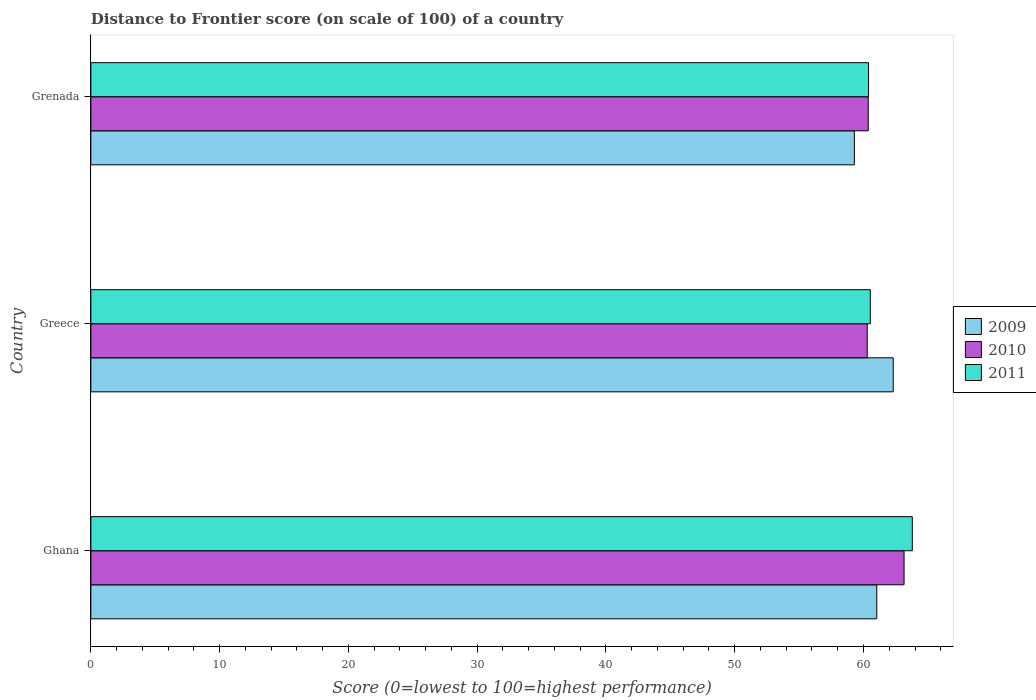How many different coloured bars are there?
Keep it short and to the point. 3. In how many cases, is the number of bars for a given country not equal to the number of legend labels?
Make the answer very short. 0. What is the distance to frontier score of in 2010 in Greece?
Keep it short and to the point. 60.29. Across all countries, what is the maximum distance to frontier score of in 2010?
Your answer should be very brief. 63.15. Across all countries, what is the minimum distance to frontier score of in 2010?
Ensure brevity in your answer.  60.29. In which country was the distance to frontier score of in 2009 maximum?
Offer a terse response. Greece. In which country was the distance to frontier score of in 2010 minimum?
Make the answer very short. Greece. What is the total distance to frontier score of in 2011 in the graph?
Your answer should be very brief. 184.71. What is the difference between the distance to frontier score of in 2009 in Ghana and that in Grenada?
Provide a succinct answer. 1.74. What is the difference between the distance to frontier score of in 2009 in Greece and the distance to frontier score of in 2010 in Grenada?
Keep it short and to the point. 1.94. What is the average distance to frontier score of in 2011 per country?
Keep it short and to the point. 61.57. What is the difference between the distance to frontier score of in 2011 and distance to frontier score of in 2009 in Grenada?
Your response must be concise. 1.1. In how many countries, is the distance to frontier score of in 2011 greater than 22 ?
Give a very brief answer. 3. What is the ratio of the distance to frontier score of in 2011 in Ghana to that in Grenada?
Give a very brief answer. 1.06. Is the distance to frontier score of in 2011 in Greece less than that in Grenada?
Give a very brief answer. No. What is the difference between the highest and the second highest distance to frontier score of in 2009?
Make the answer very short. 1.28. What is the difference between the highest and the lowest distance to frontier score of in 2010?
Your response must be concise. 2.86. What does the 3rd bar from the top in Ghana represents?
Provide a short and direct response. 2009. How many bars are there?
Your response must be concise. 9. What is the difference between two consecutive major ticks on the X-axis?
Provide a short and direct response. 10. Are the values on the major ticks of X-axis written in scientific E-notation?
Provide a succinct answer. No. Does the graph contain grids?
Offer a terse response. No. How many legend labels are there?
Make the answer very short. 3. How are the legend labels stacked?
Give a very brief answer. Vertical. What is the title of the graph?
Your answer should be very brief. Distance to Frontier score (on scale of 100) of a country. Does "1977" appear as one of the legend labels in the graph?
Your answer should be very brief. No. What is the label or title of the X-axis?
Offer a terse response. Score (0=lowest to 100=highest performance). What is the label or title of the Y-axis?
Give a very brief answer. Country. What is the Score (0=lowest to 100=highest performance) in 2009 in Ghana?
Your answer should be very brief. 61.03. What is the Score (0=lowest to 100=highest performance) in 2010 in Ghana?
Keep it short and to the point. 63.15. What is the Score (0=lowest to 100=highest performance) of 2011 in Ghana?
Your response must be concise. 63.79. What is the Score (0=lowest to 100=highest performance) in 2009 in Greece?
Your response must be concise. 62.31. What is the Score (0=lowest to 100=highest performance) of 2010 in Greece?
Make the answer very short. 60.29. What is the Score (0=lowest to 100=highest performance) in 2011 in Greece?
Offer a terse response. 60.53. What is the Score (0=lowest to 100=highest performance) of 2009 in Grenada?
Your answer should be compact. 59.29. What is the Score (0=lowest to 100=highest performance) of 2010 in Grenada?
Your response must be concise. 60.37. What is the Score (0=lowest to 100=highest performance) of 2011 in Grenada?
Offer a very short reply. 60.39. Across all countries, what is the maximum Score (0=lowest to 100=highest performance) of 2009?
Give a very brief answer. 62.31. Across all countries, what is the maximum Score (0=lowest to 100=highest performance) of 2010?
Ensure brevity in your answer.  63.15. Across all countries, what is the maximum Score (0=lowest to 100=highest performance) in 2011?
Provide a short and direct response. 63.79. Across all countries, what is the minimum Score (0=lowest to 100=highest performance) in 2009?
Your answer should be compact. 59.29. Across all countries, what is the minimum Score (0=lowest to 100=highest performance) in 2010?
Your answer should be very brief. 60.29. Across all countries, what is the minimum Score (0=lowest to 100=highest performance) in 2011?
Ensure brevity in your answer.  60.39. What is the total Score (0=lowest to 100=highest performance) in 2009 in the graph?
Provide a short and direct response. 182.63. What is the total Score (0=lowest to 100=highest performance) in 2010 in the graph?
Make the answer very short. 183.81. What is the total Score (0=lowest to 100=highest performance) of 2011 in the graph?
Your response must be concise. 184.71. What is the difference between the Score (0=lowest to 100=highest performance) in 2009 in Ghana and that in Greece?
Your response must be concise. -1.28. What is the difference between the Score (0=lowest to 100=highest performance) of 2010 in Ghana and that in Greece?
Provide a short and direct response. 2.86. What is the difference between the Score (0=lowest to 100=highest performance) of 2011 in Ghana and that in Greece?
Ensure brevity in your answer.  3.26. What is the difference between the Score (0=lowest to 100=highest performance) of 2009 in Ghana and that in Grenada?
Your answer should be compact. 1.74. What is the difference between the Score (0=lowest to 100=highest performance) of 2010 in Ghana and that in Grenada?
Your answer should be very brief. 2.78. What is the difference between the Score (0=lowest to 100=highest performance) of 2009 in Greece and that in Grenada?
Ensure brevity in your answer.  3.02. What is the difference between the Score (0=lowest to 100=highest performance) of 2010 in Greece and that in Grenada?
Make the answer very short. -0.08. What is the difference between the Score (0=lowest to 100=highest performance) in 2011 in Greece and that in Grenada?
Your response must be concise. 0.14. What is the difference between the Score (0=lowest to 100=highest performance) of 2009 in Ghana and the Score (0=lowest to 100=highest performance) of 2010 in Greece?
Offer a terse response. 0.74. What is the difference between the Score (0=lowest to 100=highest performance) in 2009 in Ghana and the Score (0=lowest to 100=highest performance) in 2011 in Greece?
Your answer should be very brief. 0.5. What is the difference between the Score (0=lowest to 100=highest performance) of 2010 in Ghana and the Score (0=lowest to 100=highest performance) of 2011 in Greece?
Ensure brevity in your answer.  2.62. What is the difference between the Score (0=lowest to 100=highest performance) of 2009 in Ghana and the Score (0=lowest to 100=highest performance) of 2010 in Grenada?
Ensure brevity in your answer.  0.66. What is the difference between the Score (0=lowest to 100=highest performance) in 2009 in Ghana and the Score (0=lowest to 100=highest performance) in 2011 in Grenada?
Offer a terse response. 0.64. What is the difference between the Score (0=lowest to 100=highest performance) in 2010 in Ghana and the Score (0=lowest to 100=highest performance) in 2011 in Grenada?
Your response must be concise. 2.76. What is the difference between the Score (0=lowest to 100=highest performance) of 2009 in Greece and the Score (0=lowest to 100=highest performance) of 2010 in Grenada?
Offer a terse response. 1.94. What is the difference between the Score (0=lowest to 100=highest performance) in 2009 in Greece and the Score (0=lowest to 100=highest performance) in 2011 in Grenada?
Your response must be concise. 1.92. What is the difference between the Score (0=lowest to 100=highest performance) in 2010 in Greece and the Score (0=lowest to 100=highest performance) in 2011 in Grenada?
Your response must be concise. -0.1. What is the average Score (0=lowest to 100=highest performance) in 2009 per country?
Offer a very short reply. 60.88. What is the average Score (0=lowest to 100=highest performance) of 2010 per country?
Your answer should be compact. 61.27. What is the average Score (0=lowest to 100=highest performance) of 2011 per country?
Provide a short and direct response. 61.57. What is the difference between the Score (0=lowest to 100=highest performance) in 2009 and Score (0=lowest to 100=highest performance) in 2010 in Ghana?
Offer a very short reply. -2.12. What is the difference between the Score (0=lowest to 100=highest performance) in 2009 and Score (0=lowest to 100=highest performance) in 2011 in Ghana?
Make the answer very short. -2.76. What is the difference between the Score (0=lowest to 100=highest performance) of 2010 and Score (0=lowest to 100=highest performance) of 2011 in Ghana?
Keep it short and to the point. -0.64. What is the difference between the Score (0=lowest to 100=highest performance) in 2009 and Score (0=lowest to 100=highest performance) in 2010 in Greece?
Your answer should be very brief. 2.02. What is the difference between the Score (0=lowest to 100=highest performance) of 2009 and Score (0=lowest to 100=highest performance) of 2011 in Greece?
Your response must be concise. 1.78. What is the difference between the Score (0=lowest to 100=highest performance) of 2010 and Score (0=lowest to 100=highest performance) of 2011 in Greece?
Your response must be concise. -0.24. What is the difference between the Score (0=lowest to 100=highest performance) of 2009 and Score (0=lowest to 100=highest performance) of 2010 in Grenada?
Your response must be concise. -1.08. What is the difference between the Score (0=lowest to 100=highest performance) of 2009 and Score (0=lowest to 100=highest performance) of 2011 in Grenada?
Provide a succinct answer. -1.1. What is the difference between the Score (0=lowest to 100=highest performance) in 2010 and Score (0=lowest to 100=highest performance) in 2011 in Grenada?
Your response must be concise. -0.02. What is the ratio of the Score (0=lowest to 100=highest performance) of 2009 in Ghana to that in Greece?
Keep it short and to the point. 0.98. What is the ratio of the Score (0=lowest to 100=highest performance) in 2010 in Ghana to that in Greece?
Keep it short and to the point. 1.05. What is the ratio of the Score (0=lowest to 100=highest performance) of 2011 in Ghana to that in Greece?
Give a very brief answer. 1.05. What is the ratio of the Score (0=lowest to 100=highest performance) in 2009 in Ghana to that in Grenada?
Your answer should be very brief. 1.03. What is the ratio of the Score (0=lowest to 100=highest performance) in 2010 in Ghana to that in Grenada?
Make the answer very short. 1.05. What is the ratio of the Score (0=lowest to 100=highest performance) in 2011 in Ghana to that in Grenada?
Your answer should be compact. 1.06. What is the ratio of the Score (0=lowest to 100=highest performance) of 2009 in Greece to that in Grenada?
Your answer should be very brief. 1.05. What is the ratio of the Score (0=lowest to 100=highest performance) in 2010 in Greece to that in Grenada?
Offer a very short reply. 1. What is the ratio of the Score (0=lowest to 100=highest performance) in 2011 in Greece to that in Grenada?
Make the answer very short. 1. What is the difference between the highest and the second highest Score (0=lowest to 100=highest performance) of 2009?
Give a very brief answer. 1.28. What is the difference between the highest and the second highest Score (0=lowest to 100=highest performance) in 2010?
Provide a succinct answer. 2.78. What is the difference between the highest and the second highest Score (0=lowest to 100=highest performance) of 2011?
Provide a succinct answer. 3.26. What is the difference between the highest and the lowest Score (0=lowest to 100=highest performance) in 2009?
Offer a terse response. 3.02. What is the difference between the highest and the lowest Score (0=lowest to 100=highest performance) in 2010?
Give a very brief answer. 2.86. What is the difference between the highest and the lowest Score (0=lowest to 100=highest performance) in 2011?
Make the answer very short. 3.4. 